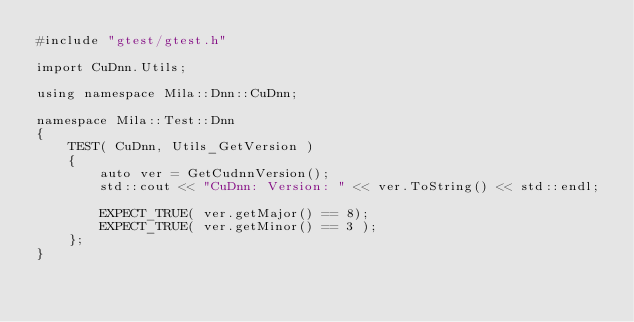Convert code to text. <code><loc_0><loc_0><loc_500><loc_500><_C++_>#include "gtest/gtest.h"

import CuDnn.Utils;

using namespace Mila::Dnn::CuDnn;

namespace Mila::Test::Dnn
{
    TEST( CuDnn, Utils_GetVersion )
    {
        auto ver = GetCudnnVersion();
        std::cout << "CuDnn: Version: " << ver.ToString() << std::endl;

        EXPECT_TRUE( ver.getMajor() == 8);
        EXPECT_TRUE( ver.getMinor() == 3 );
    };
}
</code> 